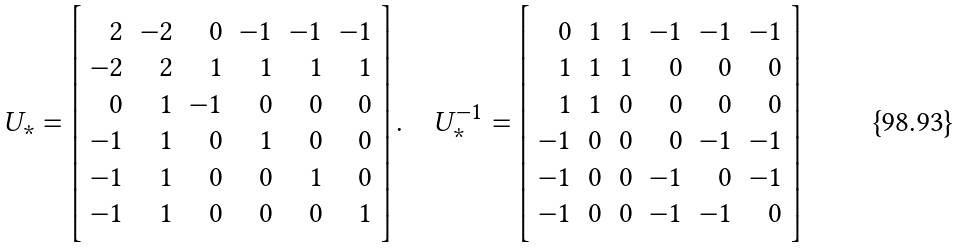<formula> <loc_0><loc_0><loc_500><loc_500>U _ { \ast } = \left [ \begin{array} { r r r r r r } 2 & - 2 & 0 & - 1 & - 1 & - 1 \\ - 2 & 2 & 1 & 1 & 1 & 1 \\ 0 & 1 & - 1 & 0 & 0 & 0 \\ - 1 & 1 & 0 & 1 & 0 & 0 \\ - 1 & 1 & 0 & 0 & 1 & 0 \\ - 1 & 1 & 0 & 0 & 0 & 1 \end{array} \right ] . \quad U _ { \ast } ^ { - 1 } = \left [ \begin{array} { r r r r r r } 0 & 1 & 1 & - 1 & - 1 & - 1 \\ 1 & 1 & 1 & 0 & 0 & 0 \\ 1 & 1 & 0 & 0 & 0 & 0 \\ - 1 & 0 & 0 & 0 & - 1 & - 1 \\ - 1 & 0 & 0 & - 1 & 0 & - 1 \\ - 1 & 0 & 0 & - 1 & - 1 & 0 \end{array} \right ]</formula> 